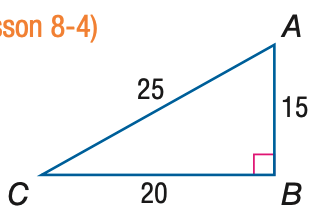Answer the mathemtical geometry problem and directly provide the correct option letter.
Question: Express the ratio of \sin C as a decimal to the nearest hundredth.
Choices: A: 0.60 B: 0.75 C: 0.80 D: 1.33 A 